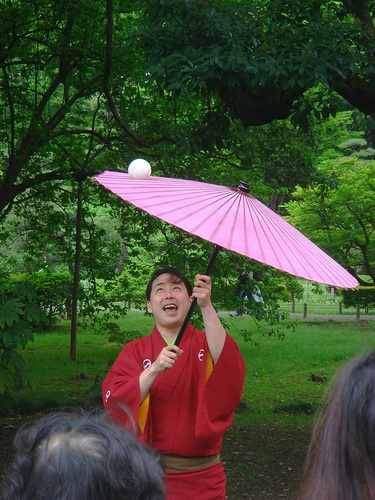Describe the objects in this image and their specific colors. I can see people in green, brown, maroon, darkgray, and gray tones, umbrella in green, violet, pink, and black tones, people in green, gray, black, and darkblue tones, people in green, gray, and black tones, and sports ball in green, white, lightpink, pink, and lightblue tones in this image. 